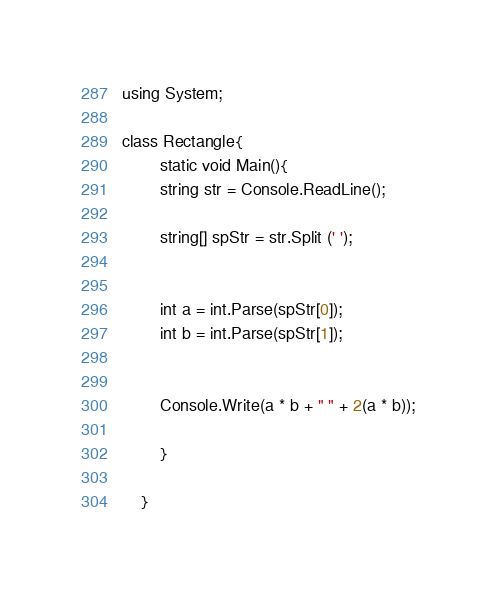<code> <loc_0><loc_0><loc_500><loc_500><_C#_>using System;

class Rectangle{
		static void Main(){
		string str = Console.ReadLine();

		string[] spStr = str.Split (' ');


		int a = int.Parse(spStr[0]);
		int b = int.Parse(spStr[1]);


		Console.Write(a * b + " " + 2(a * b));

		}

	}</code> 